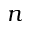<formula> <loc_0><loc_0><loc_500><loc_500>n</formula> 